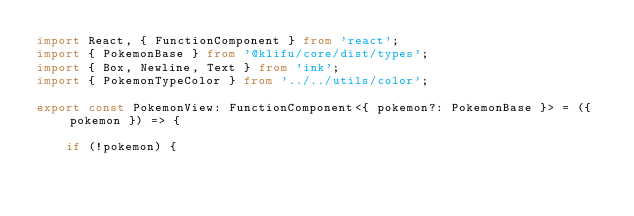<code> <loc_0><loc_0><loc_500><loc_500><_TypeScript_>import React, { FunctionComponent } from 'react';
import { PokemonBase } from '@klifu/core/dist/types';
import { Box, Newline, Text } from 'ink';
import { PokemonTypeColor } from '../../utils/color';

export const PokemonView: FunctionComponent<{ pokemon?: PokemonBase }> = ({ pokemon }) => {

	if (!pokemon) {</code> 